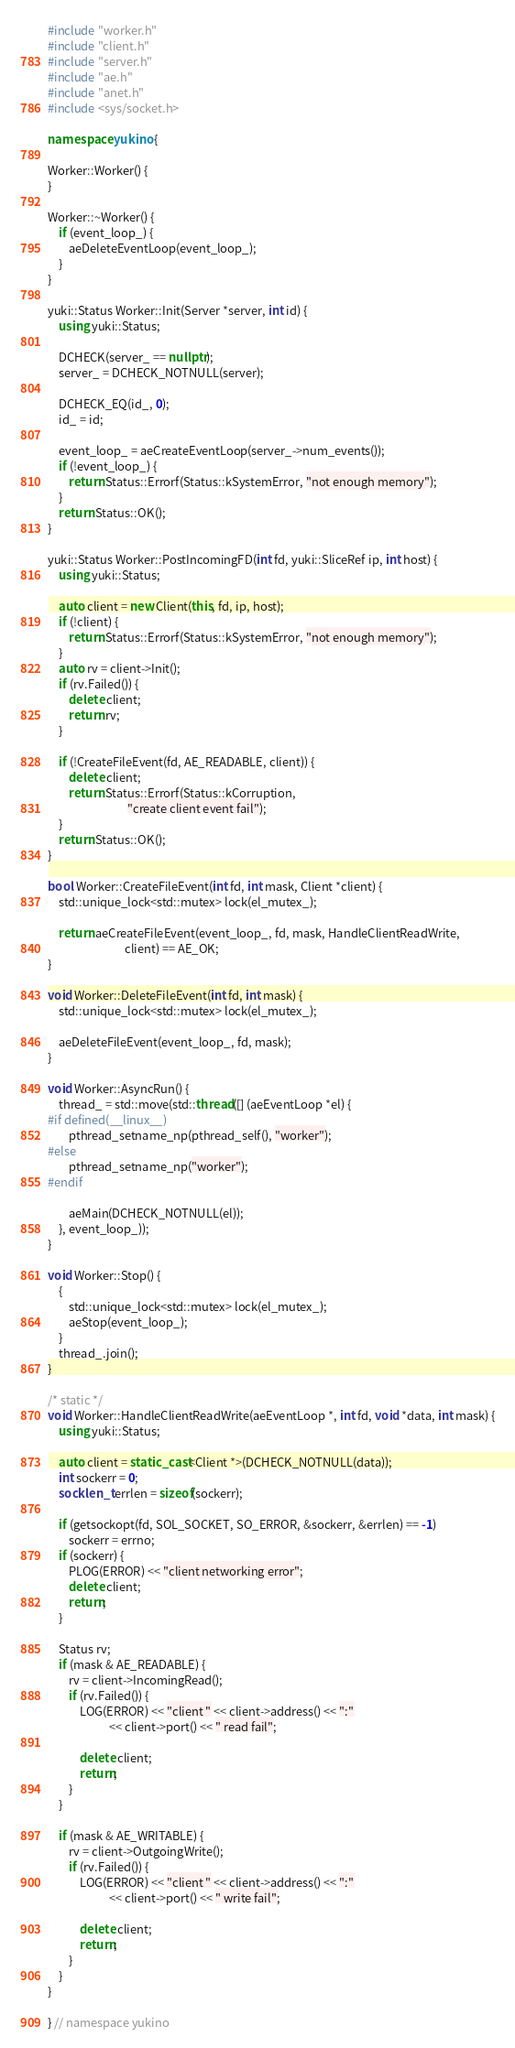Convert code to text. <code><loc_0><loc_0><loc_500><loc_500><_C++_>#include "worker.h"
#include "client.h"
#include "server.h"
#include "ae.h"
#include "anet.h"
#include <sys/socket.h>

namespace yukino {

Worker::Worker() {
}

Worker::~Worker() {
    if (event_loop_) {
        aeDeleteEventLoop(event_loop_);
    }
}

yuki::Status Worker::Init(Server *server, int id) {
    using yuki::Status;

    DCHECK(server_ == nullptr);
    server_ = DCHECK_NOTNULL(server);

    DCHECK_EQ(id_, 0);
    id_ = id;

    event_loop_ = aeCreateEventLoop(server_->num_events());
    if (!event_loop_) {
        return Status::Errorf(Status::kSystemError, "not enough memory");
    }
    return Status::OK();
}

yuki::Status Worker::PostIncomingFD(int fd, yuki::SliceRef ip, int host) {
    using yuki::Status;

    auto client = new Client(this, fd, ip, host);
    if (!client) {
        return Status::Errorf(Status::kSystemError, "not enough memory");
    }
    auto rv = client->Init();
    if (rv.Failed()) {
        delete client;
        return rv;
    }

    if (!CreateFileEvent(fd, AE_READABLE, client)) {
        delete client;
        return Status::Errorf(Status::kCorruption,
                              "create client event fail");
    }
    return Status::OK();
}

bool Worker::CreateFileEvent(int fd, int mask, Client *client) {
    std::unique_lock<std::mutex> lock(el_mutex_);

    return aeCreateFileEvent(event_loop_, fd, mask, HandleClientReadWrite,
                             client) == AE_OK;
}

void Worker::DeleteFileEvent(int fd, int mask) {
    std::unique_lock<std::mutex> lock(el_mutex_);

    aeDeleteFileEvent(event_loop_, fd, mask);
}

void Worker::AsyncRun() {
    thread_ = std::move(std::thread([] (aeEventLoop *el) {
#if defined(__linux__)
        pthread_setname_np(pthread_self(), "worker");
#else
        pthread_setname_np("worker");
#endif

        aeMain(DCHECK_NOTNULL(el));
    }, event_loop_));
}

void Worker::Stop() {
    {
        std::unique_lock<std::mutex> lock(el_mutex_);
        aeStop(event_loop_);
    }
    thread_.join();
}

/* static */
void Worker::HandleClientReadWrite(aeEventLoop *, int fd, void *data, int mask) {
    using yuki::Status;

    auto client = static_cast<Client *>(DCHECK_NOTNULL(data));
    int sockerr = 0;
    socklen_t errlen = sizeof(sockerr);

    if (getsockopt(fd, SOL_SOCKET, SO_ERROR, &sockerr, &errlen) == -1)
        sockerr = errno;
    if (sockerr) {
        PLOG(ERROR) << "client networking error";
        delete client;
        return;
    }

    Status rv;
    if (mask & AE_READABLE) {
        rv = client->IncomingRead();
        if (rv.Failed()) {
            LOG(ERROR) << "client " << client->address() << ":"
                       << client->port() << " read fail";

            delete client;
            return;
        }
    }

    if (mask & AE_WRITABLE) {
        rv = client->OutgoingWrite();
        if (rv.Failed()) {
            LOG(ERROR) << "client " << client->address() << ":"
                       << client->port() << " write fail";

            delete client;
            return;
        }
    }
}

} // namespace yukino</code> 